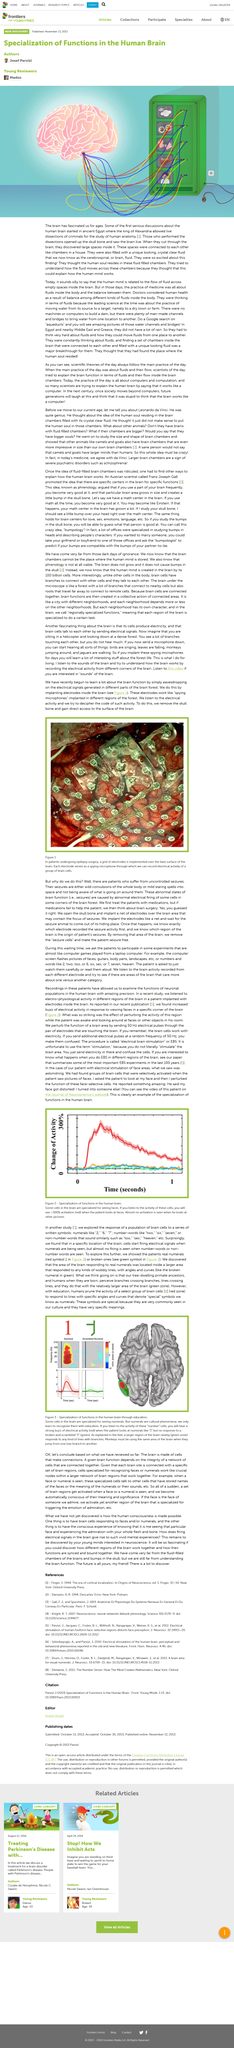Mention a couple of crucial points in this snapshot. The ancient Egyptians believed that the soul resided in the fluid-filled chambers in the brain. The name of the crystal clear fluid within the chambers of the brain is cerebrospinal fluid, also known as brain fluid. It has come to my attention that the king of Alexandria allowed for live dissections to be performed on criminal offenders. 